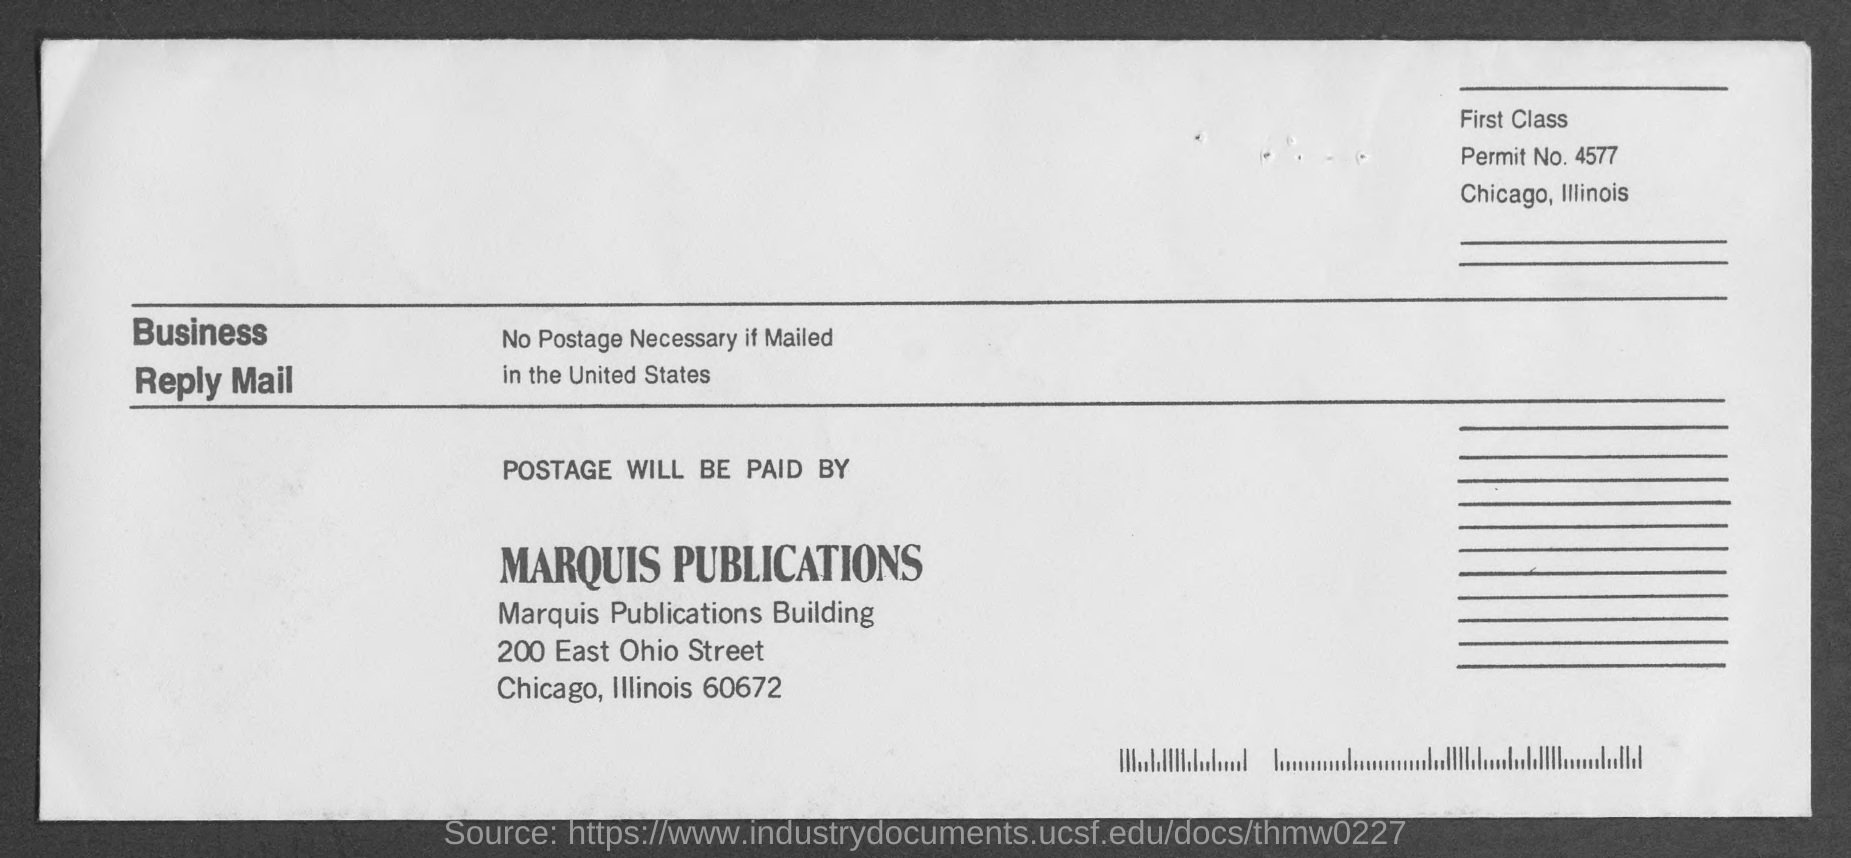What is the permit no. mentioned in the given mail ?
Provide a succinct answer. 4577. By whom the postage will be paid ?
Provide a succinct answer. Marquis publications. 